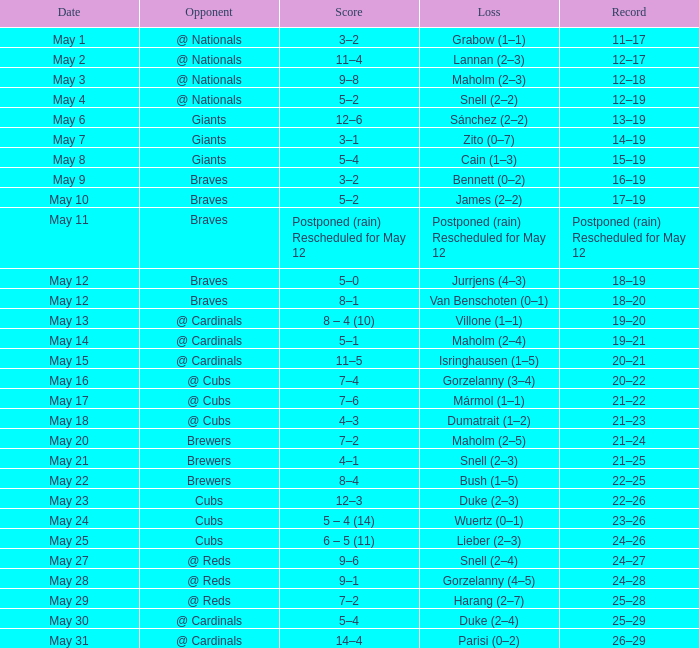Help me parse the entirety of this table. {'header': ['Date', 'Opponent', 'Score', 'Loss', 'Record'], 'rows': [['May 1', '@ Nationals', '3–2', 'Grabow (1–1)', '11–17'], ['May 2', '@ Nationals', '11–4', 'Lannan (2–3)', '12–17'], ['May 3', '@ Nationals', '9–8', 'Maholm (2–3)', '12–18'], ['May 4', '@ Nationals', '5–2', 'Snell (2–2)', '12–19'], ['May 6', 'Giants', '12–6', 'Sánchez (2–2)', '13–19'], ['May 7', 'Giants', '3–1', 'Zito (0–7)', '14–19'], ['May 8', 'Giants', '5–4', 'Cain (1–3)', '15–19'], ['May 9', 'Braves', '3–2', 'Bennett (0–2)', '16–19'], ['May 10', 'Braves', '5–2', 'James (2–2)', '17–19'], ['May 11', 'Braves', 'Postponed (rain) Rescheduled for May 12', 'Postponed (rain) Rescheduled for May 12', 'Postponed (rain) Rescheduled for May 12'], ['May 12', 'Braves', '5–0', 'Jurrjens (4–3)', '18–19'], ['May 12', 'Braves', '8–1', 'Van Benschoten (0–1)', '18–20'], ['May 13', '@ Cardinals', '8 – 4 (10)', 'Villone (1–1)', '19–20'], ['May 14', '@ Cardinals', '5–1', 'Maholm (2–4)', '19–21'], ['May 15', '@ Cardinals', '11–5', 'Isringhausen (1–5)', '20–21'], ['May 16', '@ Cubs', '7–4', 'Gorzelanny (3–4)', '20–22'], ['May 17', '@ Cubs', '7–6', 'Mármol (1–1)', '21–22'], ['May 18', '@ Cubs', '4–3', 'Dumatrait (1–2)', '21–23'], ['May 20', 'Brewers', '7–2', 'Maholm (2–5)', '21–24'], ['May 21', 'Brewers', '4–1', 'Snell (2–3)', '21–25'], ['May 22', 'Brewers', '8–4', 'Bush (1–5)', '22–25'], ['May 23', 'Cubs', '12–3', 'Duke (2–3)', '22–26'], ['May 24', 'Cubs', '5 – 4 (14)', 'Wuertz (0–1)', '23–26'], ['May 25', 'Cubs', '6 – 5 (11)', 'Lieber (2–3)', '24–26'], ['May 27', '@ Reds', '9–6', 'Snell (2–4)', '24–27'], ['May 28', '@ Reds', '9–1', 'Gorzelanny (4–5)', '24–28'], ['May 29', '@ Reds', '7–2', 'Harang (2–7)', '25–28'], ['May 30', '@ Cardinals', '5–4', 'Duke (2–4)', '25–29'], ['May 31', '@ Cardinals', '14–4', 'Parisi (0–2)', '26–29']]} On what date did the game occur in which bush was defeated (1-5)? May 22. 